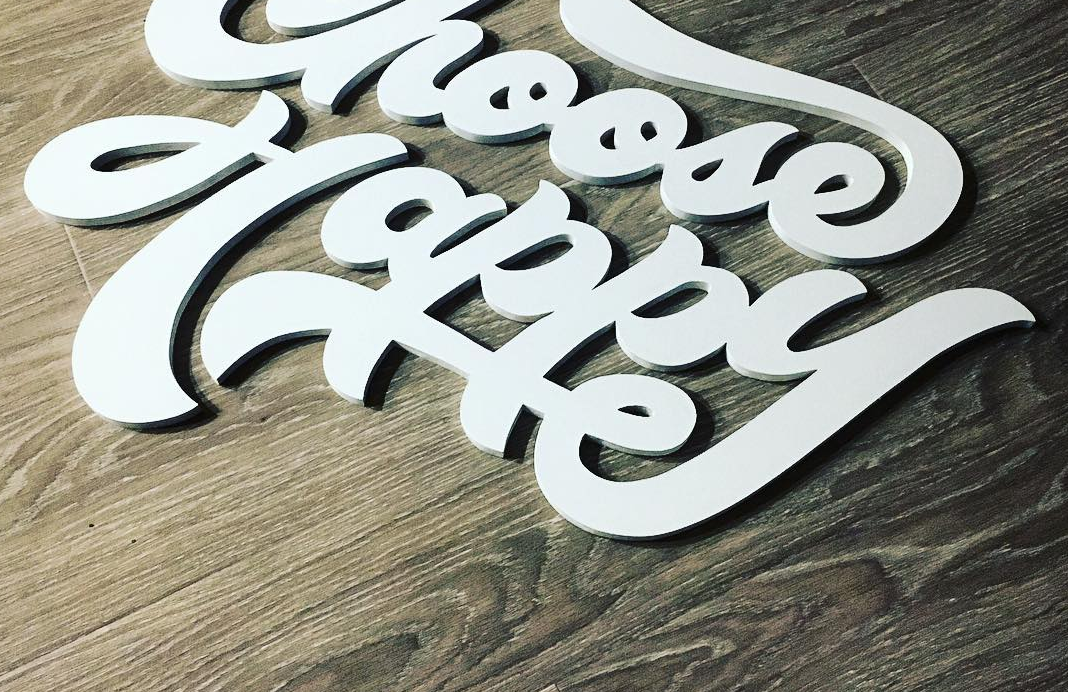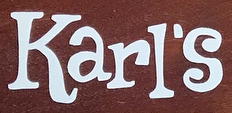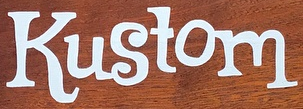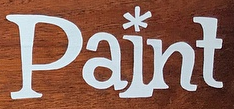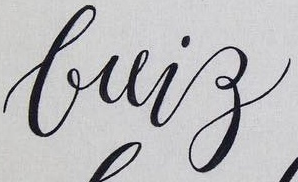What words can you see in these images in sequence, separated by a semicolon? Happy; Karl's; Kustom; Paint; brig 